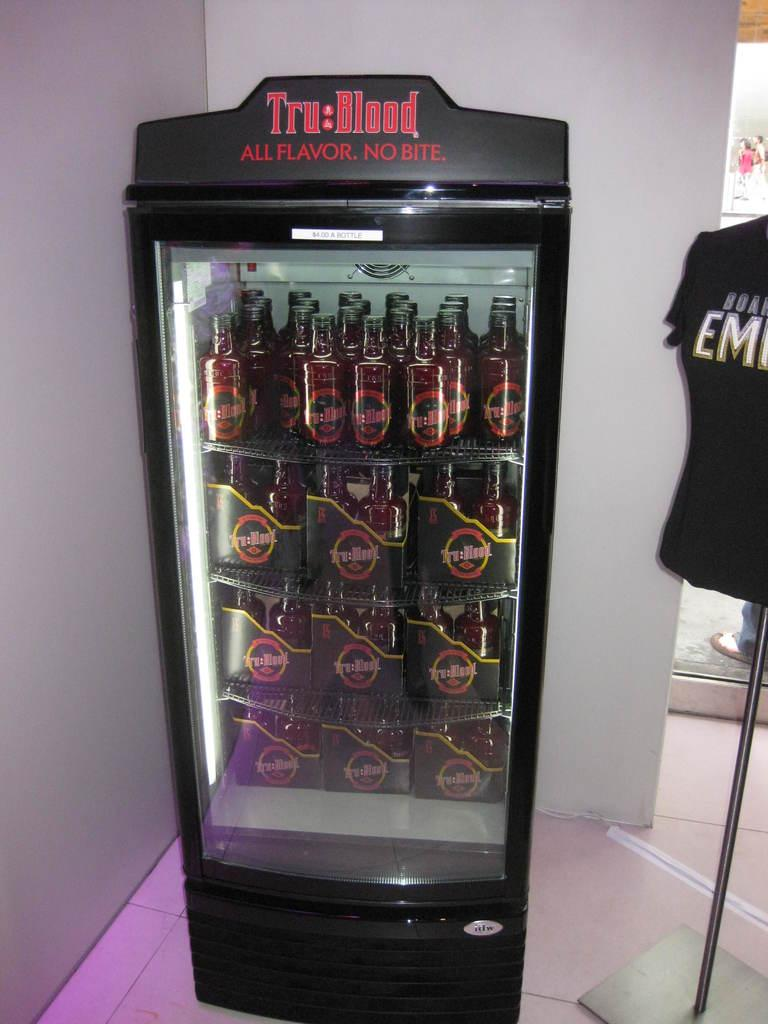Provide a one-sentence caption for the provided image. A black vending machine filled with bottles of Tru Blood. 